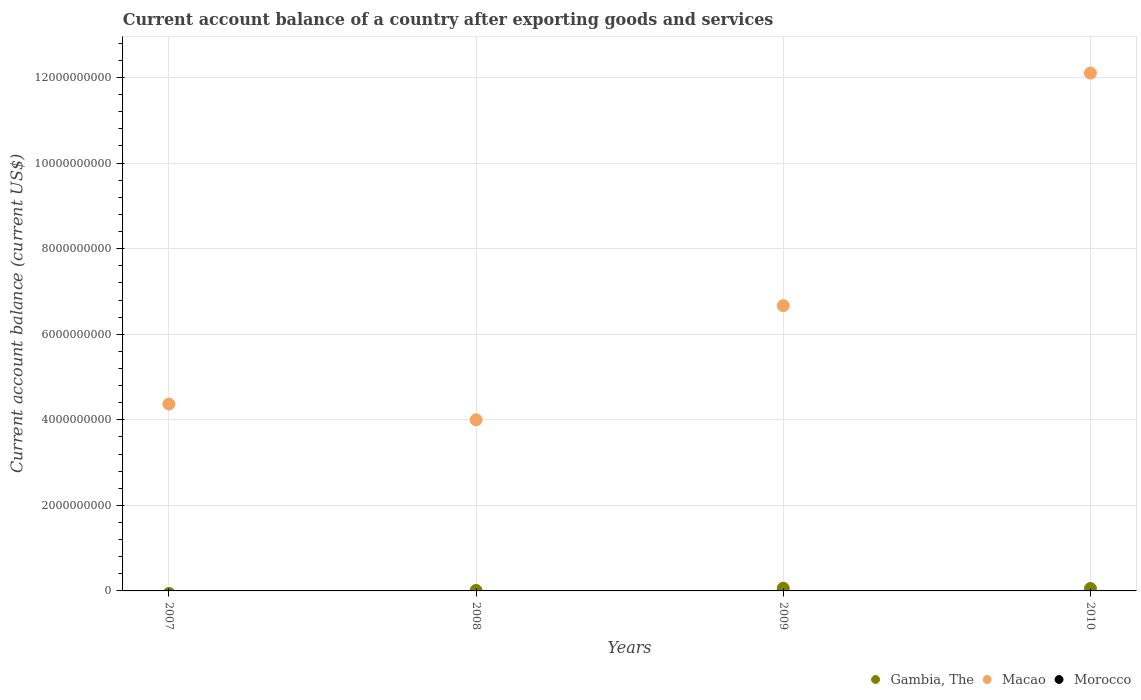Is the number of dotlines equal to the number of legend labels?
Offer a very short reply. No. What is the account balance in Macao in 2007?
Provide a succinct answer. 4.37e+09. Across all years, what is the maximum account balance in Macao?
Make the answer very short. 1.21e+1. Across all years, what is the minimum account balance in Morocco?
Ensure brevity in your answer.  0. What is the total account balance in Macao in the graph?
Your answer should be very brief. 2.71e+1. What is the difference between the account balance in Macao in 2007 and that in 2008?
Provide a short and direct response. 3.69e+08. What is the difference between the account balance in Macao in 2010 and the account balance in Gambia, The in 2008?
Provide a succinct answer. 1.21e+1. What is the average account balance in Macao per year?
Provide a succinct answer. 6.79e+09. In the year 2009, what is the difference between the account balance in Macao and account balance in Gambia, The?
Provide a succinct answer. 6.61e+09. In how many years, is the account balance in Gambia, The greater than 5200000000 US$?
Keep it short and to the point. 0. What is the ratio of the account balance in Macao in 2008 to that in 2009?
Keep it short and to the point. 0.6. Is the account balance in Gambia, The in 2008 less than that in 2009?
Your response must be concise. Yes. Is the difference between the account balance in Macao in 2008 and 2010 greater than the difference between the account balance in Gambia, The in 2008 and 2010?
Your answer should be very brief. No. What is the difference between the highest and the second highest account balance in Macao?
Ensure brevity in your answer.  5.44e+09. What is the difference between the highest and the lowest account balance in Gambia, The?
Provide a short and direct response. 6.30e+07. Is it the case that in every year, the sum of the account balance in Macao and account balance in Morocco  is greater than the account balance in Gambia, The?
Give a very brief answer. Yes. Does the account balance in Gambia, The monotonically increase over the years?
Offer a terse response. No. Is the account balance in Morocco strictly greater than the account balance in Macao over the years?
Provide a short and direct response. No. Where does the legend appear in the graph?
Give a very brief answer. Bottom right. How many legend labels are there?
Keep it short and to the point. 3. How are the legend labels stacked?
Offer a terse response. Horizontal. What is the title of the graph?
Your response must be concise. Current account balance of a country after exporting goods and services. What is the label or title of the X-axis?
Provide a succinct answer. Years. What is the label or title of the Y-axis?
Your answer should be very brief. Current account balance (current US$). What is the Current account balance (current US$) of Gambia, The in 2007?
Offer a very short reply. 0. What is the Current account balance (current US$) in Macao in 2007?
Your answer should be compact. 4.37e+09. What is the Current account balance (current US$) of Gambia, The in 2008?
Make the answer very short. 1.09e+07. What is the Current account balance (current US$) of Macao in 2008?
Provide a short and direct response. 4.00e+09. What is the Current account balance (current US$) of Gambia, The in 2009?
Make the answer very short. 6.30e+07. What is the Current account balance (current US$) of Macao in 2009?
Your answer should be compact. 6.67e+09. What is the Current account balance (current US$) in Morocco in 2009?
Give a very brief answer. 0. What is the Current account balance (current US$) in Gambia, The in 2010?
Provide a succinct answer. 5.63e+07. What is the Current account balance (current US$) in Macao in 2010?
Your answer should be compact. 1.21e+1. What is the Current account balance (current US$) of Morocco in 2010?
Your answer should be compact. 0. Across all years, what is the maximum Current account balance (current US$) in Gambia, The?
Keep it short and to the point. 6.30e+07. Across all years, what is the maximum Current account balance (current US$) of Macao?
Keep it short and to the point. 1.21e+1. Across all years, what is the minimum Current account balance (current US$) of Gambia, The?
Provide a short and direct response. 0. Across all years, what is the minimum Current account balance (current US$) of Macao?
Provide a short and direct response. 4.00e+09. What is the total Current account balance (current US$) of Gambia, The in the graph?
Keep it short and to the point. 1.30e+08. What is the total Current account balance (current US$) of Macao in the graph?
Provide a short and direct response. 2.71e+1. What is the total Current account balance (current US$) in Morocco in the graph?
Provide a short and direct response. 0. What is the difference between the Current account balance (current US$) in Macao in 2007 and that in 2008?
Your response must be concise. 3.69e+08. What is the difference between the Current account balance (current US$) in Macao in 2007 and that in 2009?
Keep it short and to the point. -2.30e+09. What is the difference between the Current account balance (current US$) of Macao in 2007 and that in 2010?
Your answer should be compact. -7.74e+09. What is the difference between the Current account balance (current US$) of Gambia, The in 2008 and that in 2009?
Provide a short and direct response. -5.21e+07. What is the difference between the Current account balance (current US$) in Macao in 2008 and that in 2009?
Keep it short and to the point. -2.67e+09. What is the difference between the Current account balance (current US$) in Gambia, The in 2008 and that in 2010?
Give a very brief answer. -4.54e+07. What is the difference between the Current account balance (current US$) in Macao in 2008 and that in 2010?
Your answer should be very brief. -8.10e+09. What is the difference between the Current account balance (current US$) of Gambia, The in 2009 and that in 2010?
Offer a terse response. 6.74e+06. What is the difference between the Current account balance (current US$) in Macao in 2009 and that in 2010?
Provide a succinct answer. -5.44e+09. What is the difference between the Current account balance (current US$) of Gambia, The in 2008 and the Current account balance (current US$) of Macao in 2009?
Provide a short and direct response. -6.66e+09. What is the difference between the Current account balance (current US$) in Gambia, The in 2008 and the Current account balance (current US$) in Macao in 2010?
Offer a very short reply. -1.21e+1. What is the difference between the Current account balance (current US$) of Gambia, The in 2009 and the Current account balance (current US$) of Macao in 2010?
Keep it short and to the point. -1.20e+1. What is the average Current account balance (current US$) of Gambia, The per year?
Offer a terse response. 3.25e+07. What is the average Current account balance (current US$) in Macao per year?
Offer a very short reply. 6.79e+09. In the year 2008, what is the difference between the Current account balance (current US$) in Gambia, The and Current account balance (current US$) in Macao?
Offer a terse response. -3.99e+09. In the year 2009, what is the difference between the Current account balance (current US$) in Gambia, The and Current account balance (current US$) in Macao?
Make the answer very short. -6.61e+09. In the year 2010, what is the difference between the Current account balance (current US$) of Gambia, The and Current account balance (current US$) of Macao?
Your response must be concise. -1.20e+1. What is the ratio of the Current account balance (current US$) of Macao in 2007 to that in 2008?
Give a very brief answer. 1.09. What is the ratio of the Current account balance (current US$) in Macao in 2007 to that in 2009?
Ensure brevity in your answer.  0.66. What is the ratio of the Current account balance (current US$) of Macao in 2007 to that in 2010?
Your answer should be compact. 0.36. What is the ratio of the Current account balance (current US$) in Gambia, The in 2008 to that in 2009?
Provide a succinct answer. 0.17. What is the ratio of the Current account balance (current US$) of Macao in 2008 to that in 2009?
Ensure brevity in your answer.  0.6. What is the ratio of the Current account balance (current US$) in Gambia, The in 2008 to that in 2010?
Ensure brevity in your answer.  0.19. What is the ratio of the Current account balance (current US$) in Macao in 2008 to that in 2010?
Keep it short and to the point. 0.33. What is the ratio of the Current account balance (current US$) of Gambia, The in 2009 to that in 2010?
Your answer should be very brief. 1.12. What is the ratio of the Current account balance (current US$) in Macao in 2009 to that in 2010?
Your response must be concise. 0.55. What is the difference between the highest and the second highest Current account balance (current US$) in Gambia, The?
Keep it short and to the point. 6.74e+06. What is the difference between the highest and the second highest Current account balance (current US$) in Macao?
Your answer should be very brief. 5.44e+09. What is the difference between the highest and the lowest Current account balance (current US$) of Gambia, The?
Keep it short and to the point. 6.30e+07. What is the difference between the highest and the lowest Current account balance (current US$) of Macao?
Your answer should be very brief. 8.10e+09. 